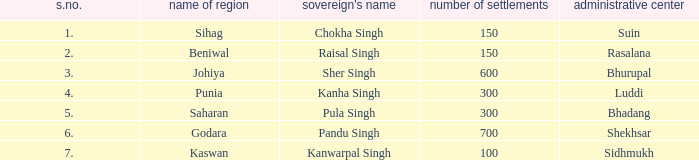I'm looking to parse the entire table for insights. Could you assist me with that? {'header': ['s.no.', 'name of region', "sovereign's name", 'number of settlements', 'administrative center'], 'rows': [['1.', 'Sihag', 'Chokha Singh', '150', 'Suin'], ['2.', 'Beniwal', 'Raisal Singh', '150', 'Rasalana'], ['3.', 'Johiya', 'Sher Singh', '600', 'Bhurupal'], ['4.', 'Punia', 'Kanha Singh', '300', 'Luddi'], ['5.', 'Saharan', 'Pula Singh', '300', 'Bhadang'], ['6.', 'Godara', 'Pandu Singh', '700', 'Shekhsar'], ['7.', 'Kaswan', 'Kanwarpal Singh', '100', 'Sidhmukh']]} What king has an S. number over 1 and a number of villages of 600? Sher Singh. 